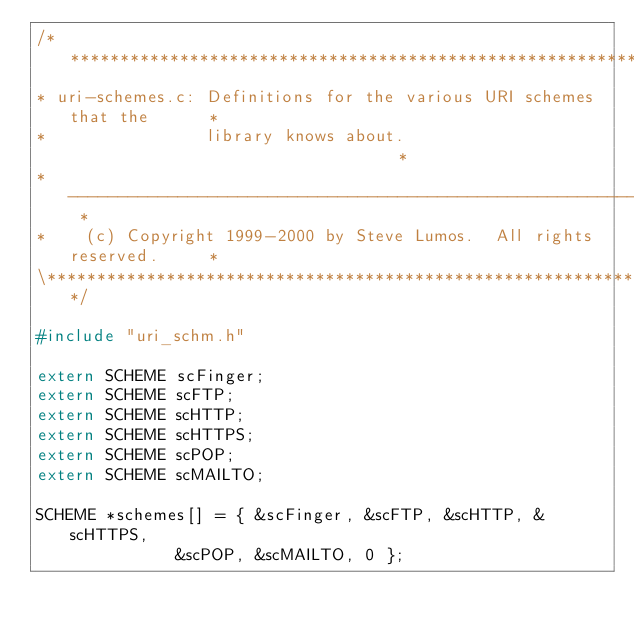Convert code to text. <code><loc_0><loc_0><loc_500><loc_500><_C_>/**********************************************************************\
* uri-schemes.c: Definitions for the various URI schemes that the      *
*                library knows about.                                  *
* -------------------------------------------------------------------- *
*    (c) Copyright 1999-2000 by Steve Lumos.  All rights reserved.     *
\**********************************************************************/

#include "uri_schm.h"

extern SCHEME scFinger;
extern SCHEME scFTP;
extern SCHEME scHTTP;
extern SCHEME scHTTPS;
extern SCHEME scPOP;
extern SCHEME scMAILTO;

SCHEME *schemes[] = { &scFinger, &scFTP, &scHTTP, &scHTTPS,
		      &scPOP, &scMAILTO, 0 };
</code> 